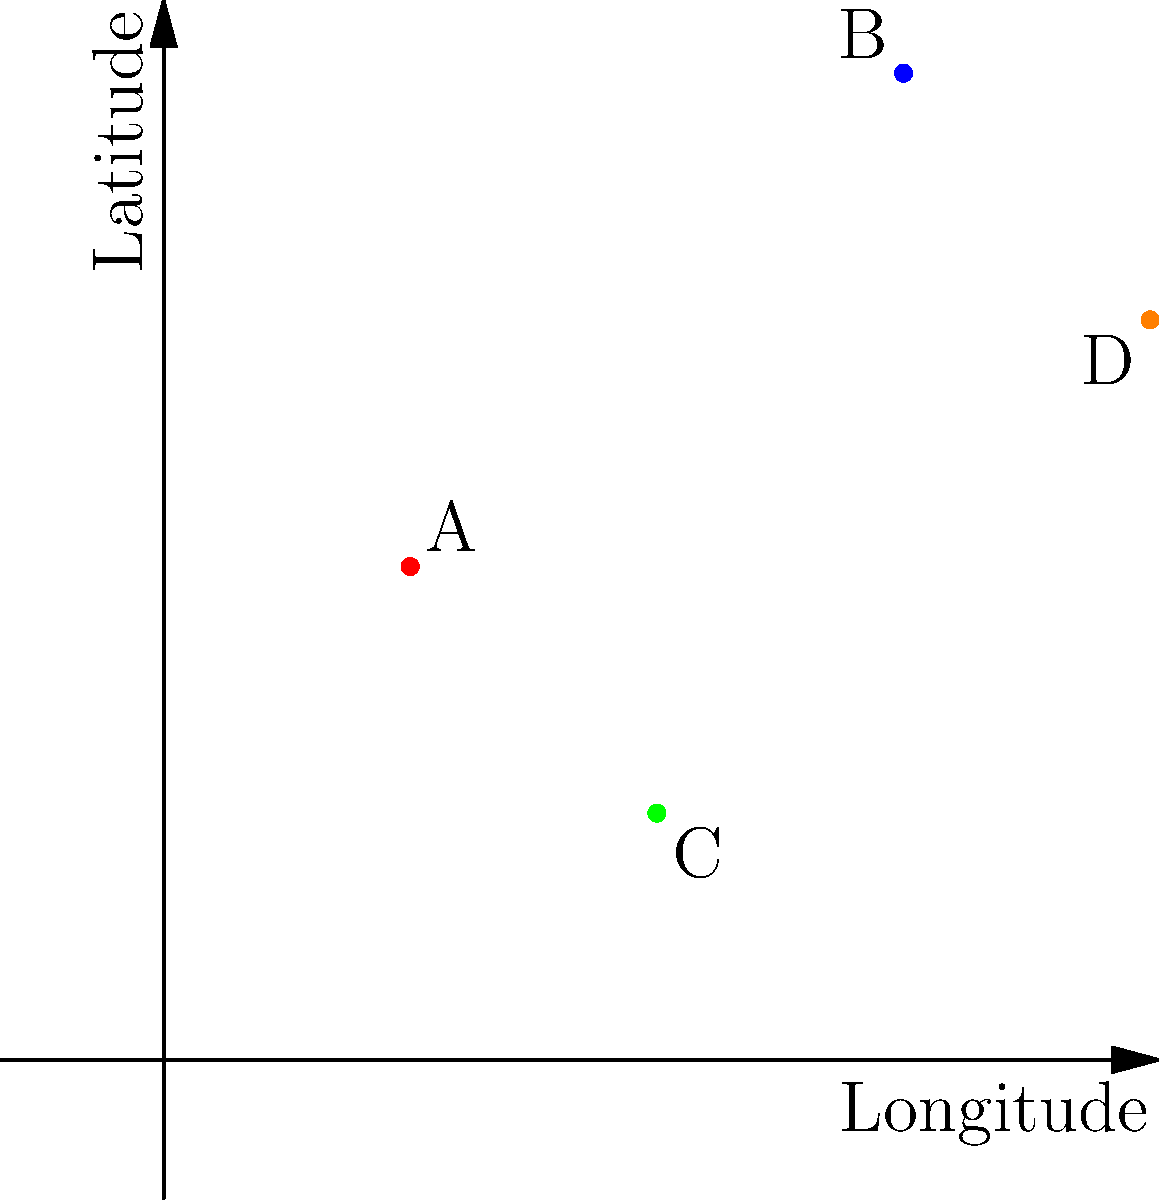On the map grid above, four landmark constitutional cases are represented by points A, B, C, and D. If point A represents the case Marbury v. Madison (1803) and point D represents Brown v. Board of Education (1954), which point is most likely to represent Plessy v. Ferguson (1896), and why? To answer this question, we need to consider the chronological order and geographical context of these landmark cases:

1. Marbury v. Madison (1803) - Point A
   This case originated in Washington D.C., which would be relatively central on a U.S. map.

2. Plessy v. Ferguson (1896)
   This case originated in Louisiana, which would be in the southern part of the U.S.

3. Brown v. Board of Education (1954) - Point D
   This case originated in Kansas, which would be more central and slightly northern on a U.S. map.

4. Chronological order: A (1803) → Plessy (1896) → D (1954)

5. Geographical considerations:
   - Point B is the northernmost point, which is unlikely for a southern case like Plessy.
   - Point C is the southernmost point, making it the most likely candidate for Plessy v. Ferguson.

6. The placement of C relative to A and D also aligns with the chronological progression, as it falls between them on the map.

Therefore, Point C is most likely to represent Plessy v. Ferguson (1896) due to its southern location on the grid and its position relative to the other known cases.
Answer: Point C 